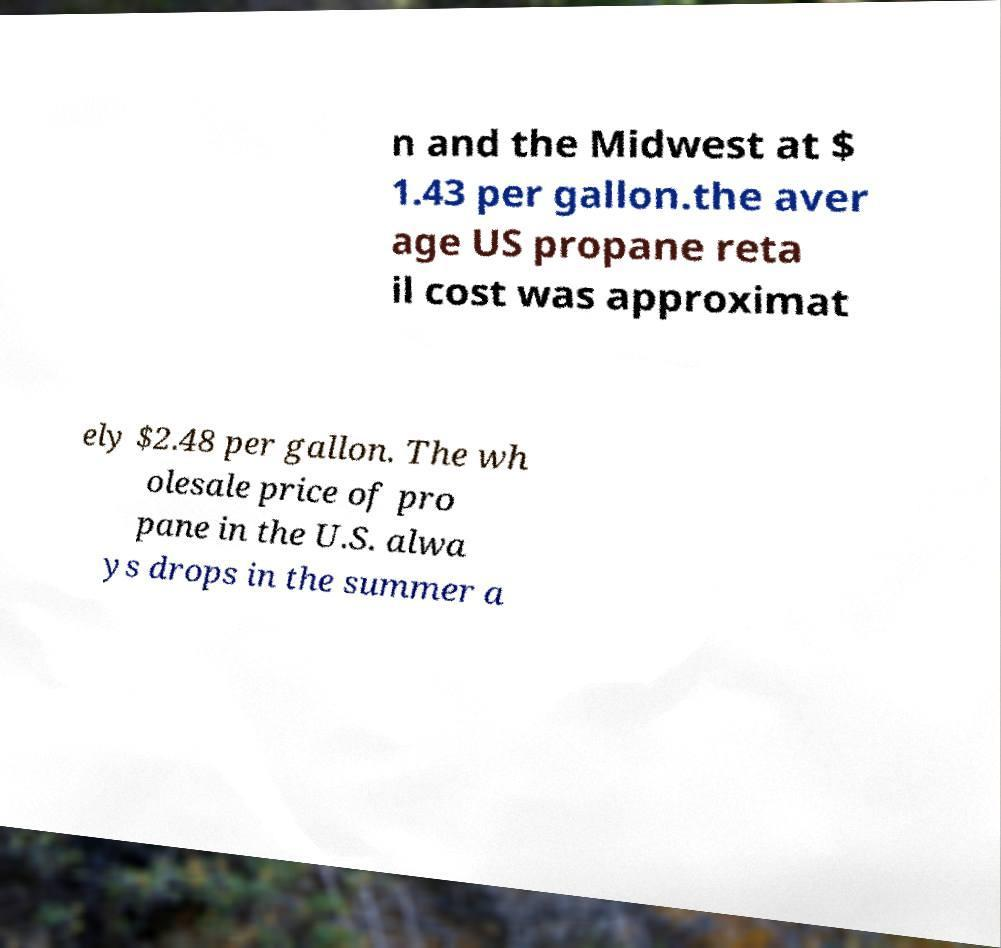Please read and relay the text visible in this image. What does it say? n and the Midwest at $ 1.43 per gallon.the aver age US propane reta il cost was approximat ely $2.48 per gallon. The wh olesale price of pro pane in the U.S. alwa ys drops in the summer a 